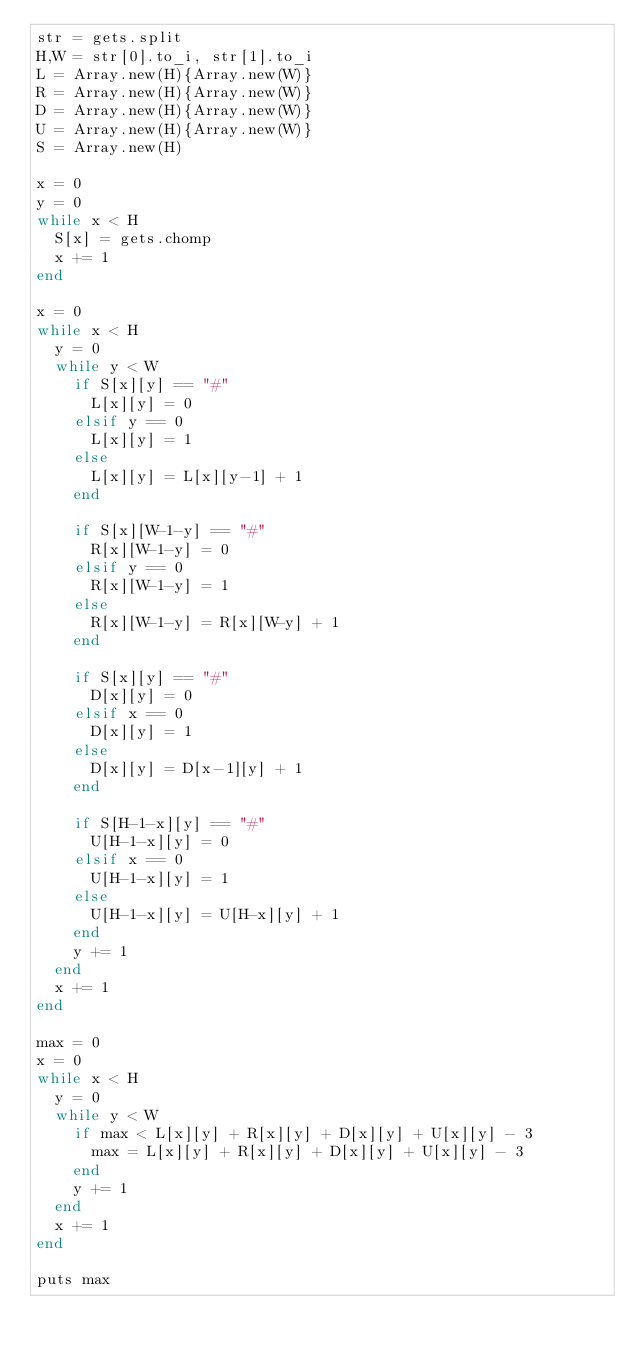<code> <loc_0><loc_0><loc_500><loc_500><_Ruby_>str = gets.split
H,W = str[0].to_i, str[1].to_i
L = Array.new(H){Array.new(W)}
R = Array.new(H){Array.new(W)}
D = Array.new(H){Array.new(W)}
U = Array.new(H){Array.new(W)}
S = Array.new(H)

x = 0
y = 0
while x < H
  S[x] = gets.chomp
  x += 1
end

x = 0
while x < H
  y = 0
  while y < W
    if S[x][y] == "#"
      L[x][y] = 0
    elsif y == 0
      L[x][y] = 1
    else
      L[x][y] = L[x][y-1] + 1
    end

    if S[x][W-1-y] == "#"
      R[x][W-1-y] = 0
    elsif y == 0
      R[x][W-1-y] = 1
    else
      R[x][W-1-y] = R[x][W-y] + 1
    end

    if S[x][y] == "#"
      D[x][y] = 0
    elsif x == 0
      D[x][y] = 1
    else
      D[x][y] = D[x-1][y] + 1
    end

    if S[H-1-x][y] == "#"
      U[H-1-x][y] = 0
    elsif x == 0
      U[H-1-x][y] = 1
    else
      U[H-1-x][y] = U[H-x][y] + 1
    end
    y += 1
  end
  x += 1
end

max = 0
x = 0
while x < H
  y = 0
  while y < W
    if max < L[x][y] + R[x][y] + D[x][y] + U[x][y] - 3
      max = L[x][y] + R[x][y] + D[x][y] + U[x][y] - 3
    end
    y += 1
  end
  x += 1
end

puts max</code> 